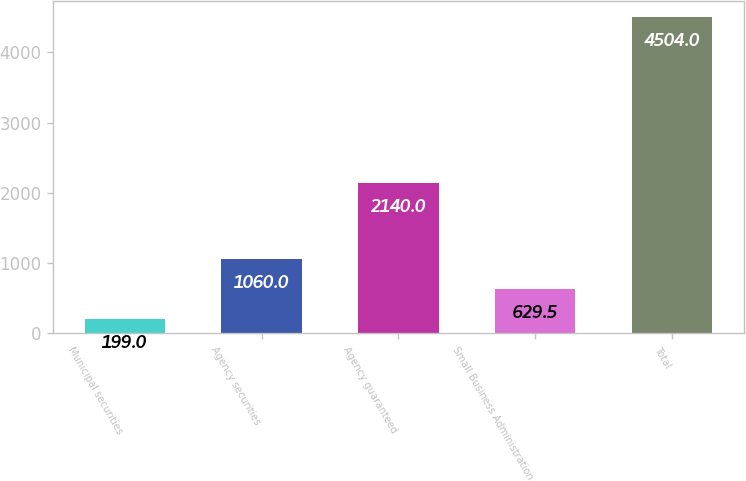Convert chart. <chart><loc_0><loc_0><loc_500><loc_500><bar_chart><fcel>Municipal securities<fcel>Agency securities<fcel>Agency guaranteed<fcel>Small Business Administration<fcel>Total<nl><fcel>199<fcel>1060<fcel>2140<fcel>629.5<fcel>4504<nl></chart> 